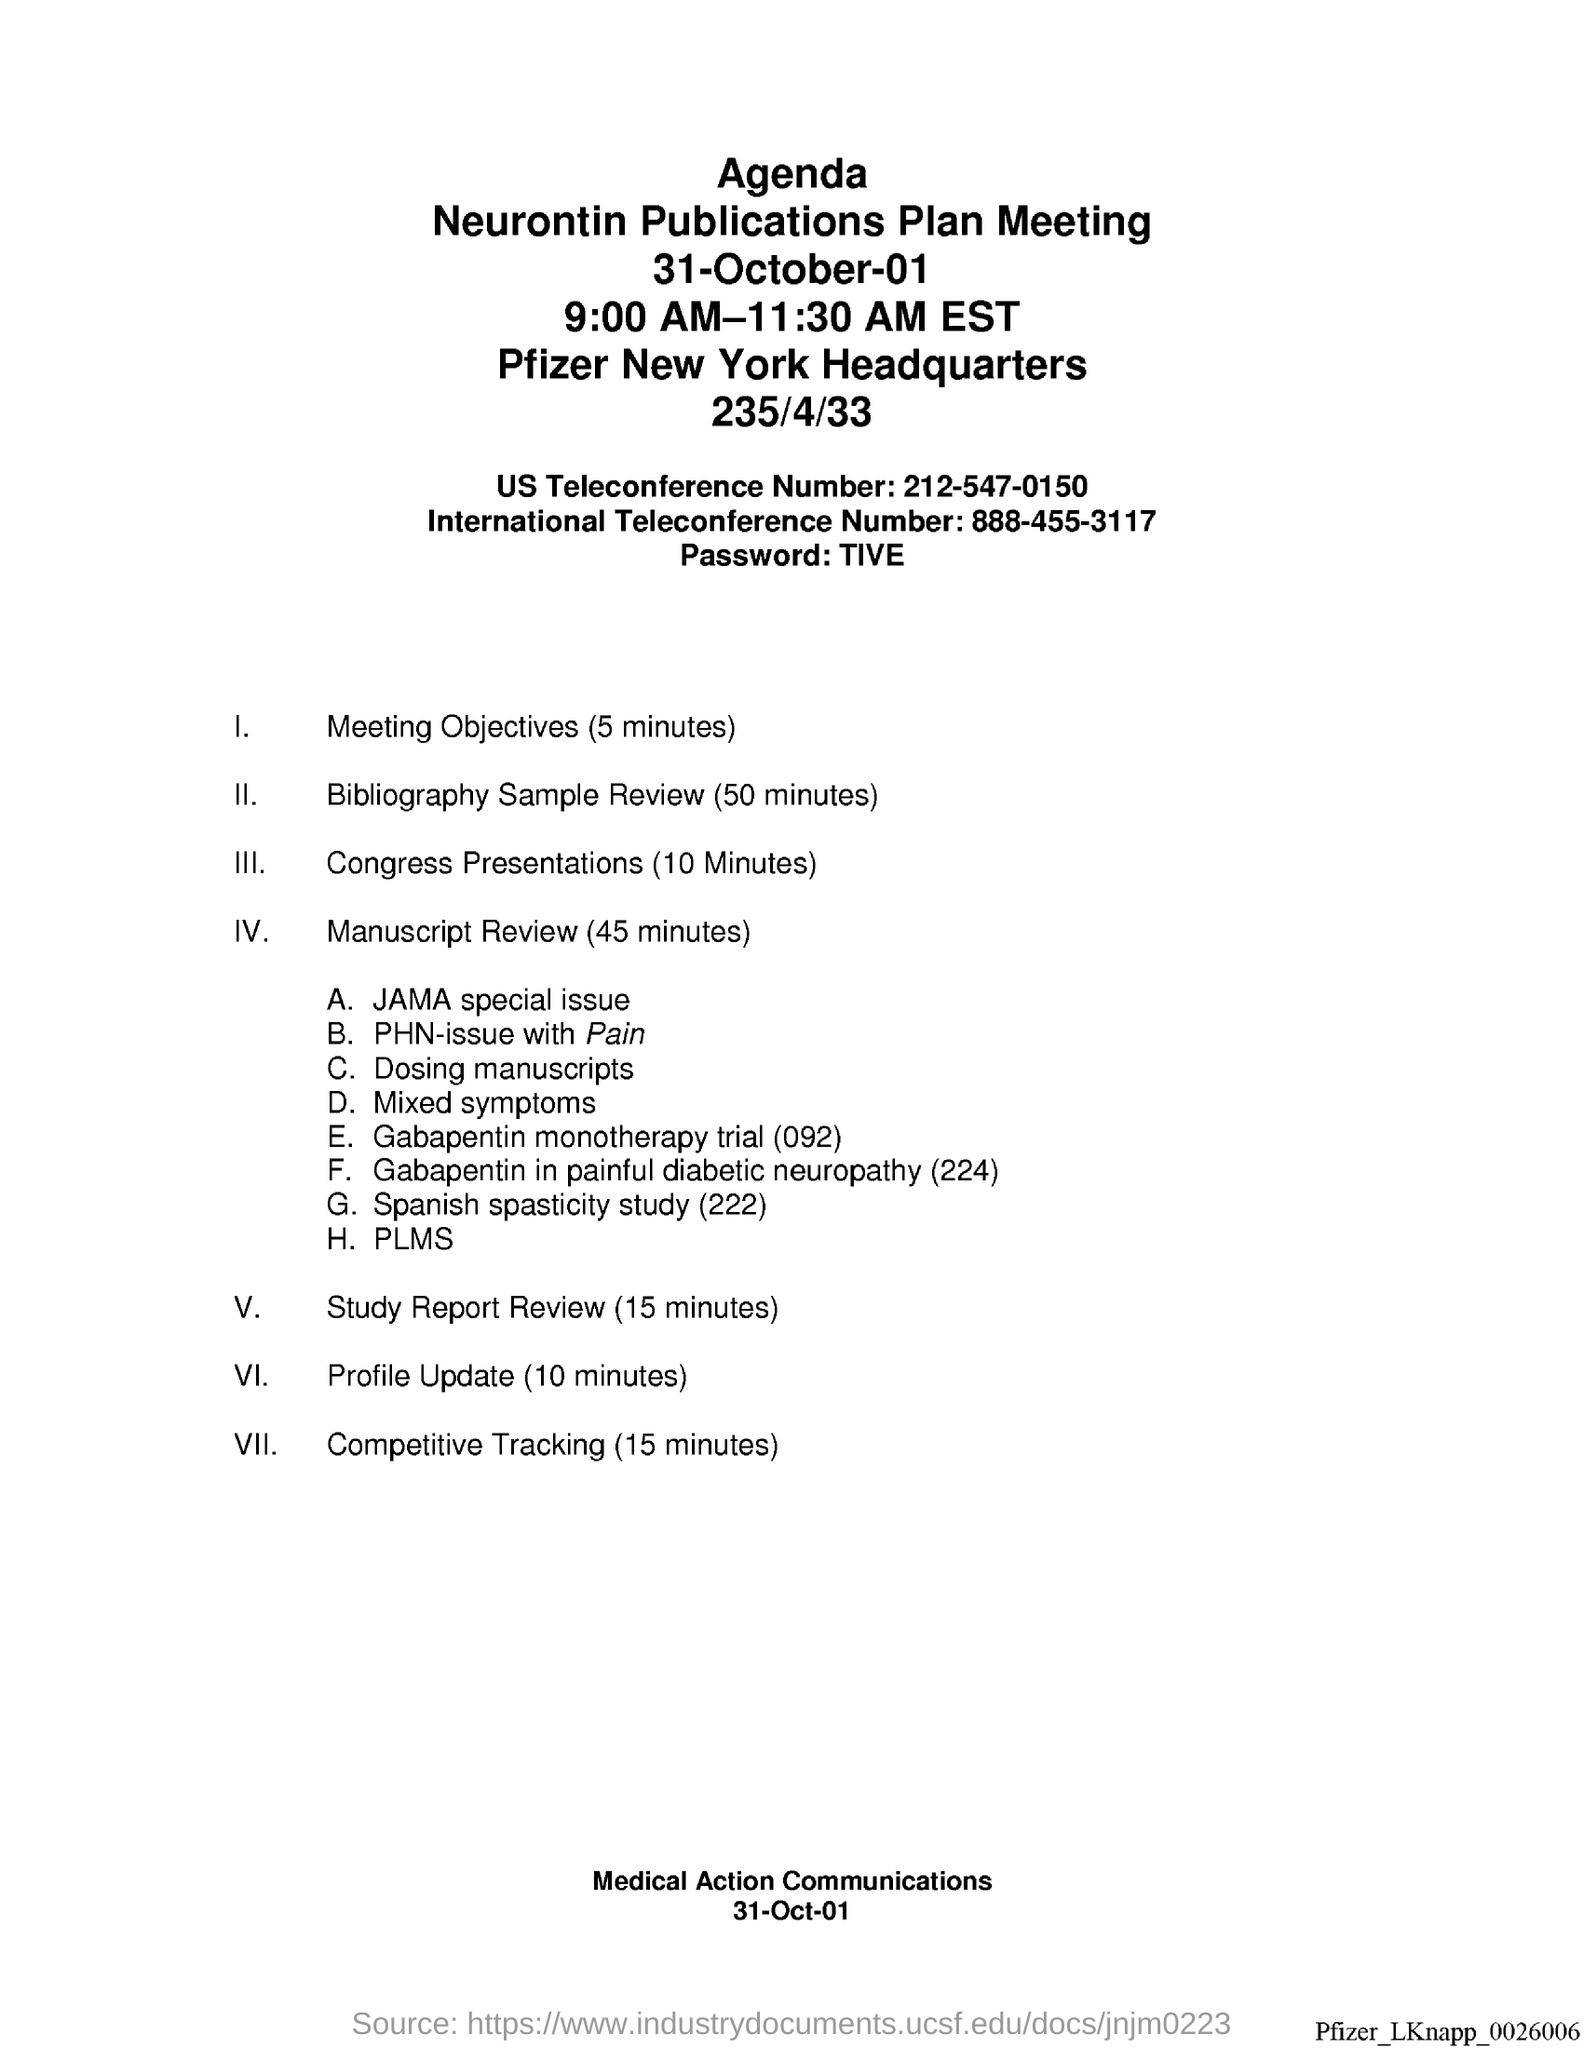What is the international teleconference number ?
Offer a very short reply. 888-455-3117. What is the password?
Make the answer very short. TIVE. What is the us teleconference number ?
Give a very brief answer. 212-547-0150. What is the date at bottom of the page?
Provide a short and direct response. 31-Oct-01. 